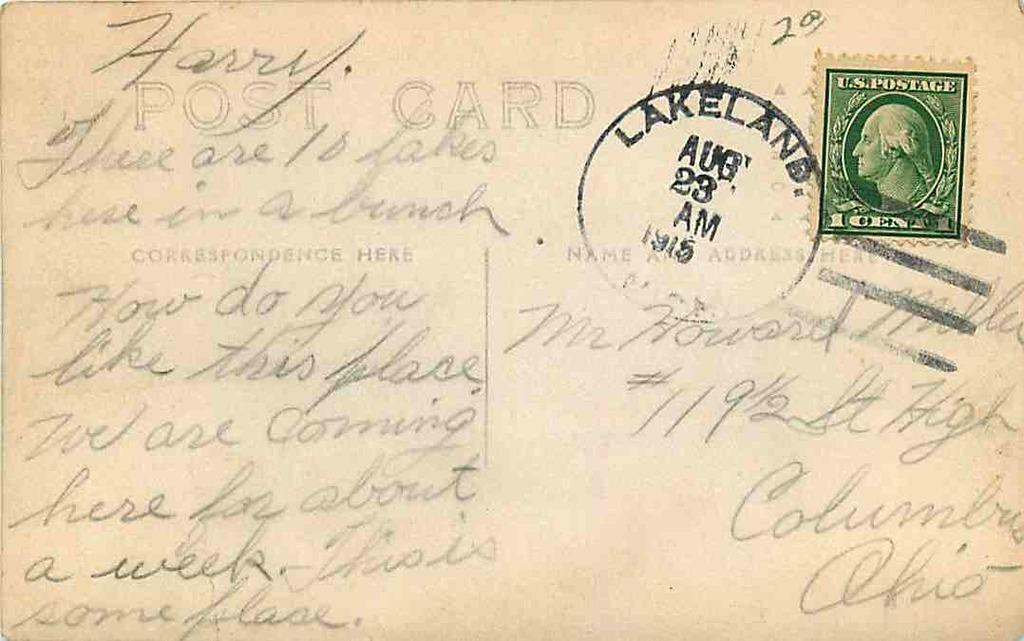What is the primary object in the image? There is a paper in the image. What can be seen on the paper? There is a stamp pasted on the paper, and there is printed text and handwritten text on the paper. What language is the elbow written in on the paper? There is no mention of an elbow on the paper, and therefore no language can be associated with it. 